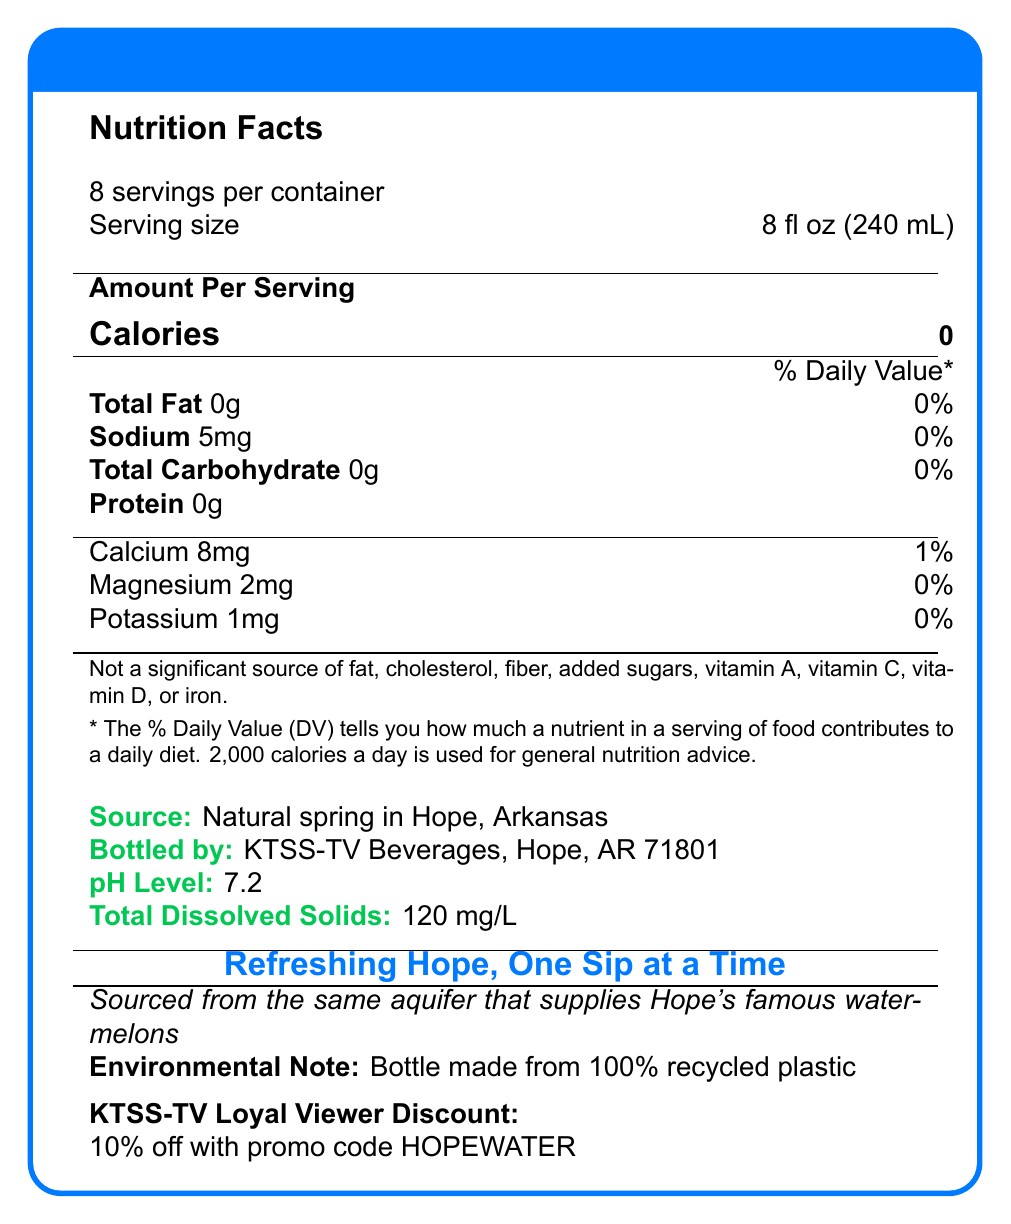What is the sodium content per serving of KTSS-TV Spring Water? The document lists "Sodium" with an amount of "5mg" per serving in the Nutrition Facts section.
Answer: 5 mg What is the daily value percentage of Calcium in a serving of KTSS-TV Spring Water? The document shows "Calcium" with an amount of "8mg" and a daily value percentage of "1%" in the Nutrition Facts section.
Answer: 1% How many servings are there in one container of KTSS-TV Spring Water? The document states "8 servings per container" under the Nutrition Facts header.
Answer: 8 Which minerals are listed in the Nutrition Facts of KTSS-TV Spring Water? The document lists "Calcium", "Magnesium", and "Potassium" with their respective amounts and daily values in the Nutrition Facts section.
Answer: Calcium, Magnesium, Potassium What is the pH level of KTSS-TV Spring Water? The document specifies a "pH Level" of "7.2" in the additional information section.
Answer: 7.2 What is the source of KTSS-TV Spring Water? A. Natural spring in Little Rock, AR B. Natural spring in Hope, AR C. Natural spring in Texarkana, AR The document specifies that the source is a "Natural spring in Hope, Arkansas."
Answer: B What is the amount of total dissolved solids in KTSS-TV Spring Water? A. 100 mg/L B. 110 mg/L C. 120 mg/L The document states "Total Dissolved Solids: 120 mg/L" in the environmental information section.
Answer: C Which nutrient is not a significant source in KTSS-TV Spring Water? A. Vitamin A B. Iron C. Fiber D. All of the above The FDA statement in the document mentions all listed nutrients including vitamin A, iron, and fiber as not significant sources.
Answer: D Is KTSS-TV Spring Water a good source of protein? The Nutrition Facts label indicates that the water contains "0g" of protein per serving.
Answer: No Summarize the main idea of the KTSS-TV Spring Water document. KTSS-TV Spring Water offers a healthy hydration option with minimal mineral content, sourced locally and packaged in environmentally friendly bottles, emphasizing its connection to the Hope, Arkansas community.
Answer: KTSS-TV Spring Water is a bottled water product with no calories, fat, carbs, or protein. It contains small amounts of sodium, calcium, magnesium, and potassium. The water is sourced from a natural spring in Hope, Arkansas, has a pH level of 7.2, and has 120 mg/L of total dissolved solids. The bottle is made from recycled plastic, and loyal viewers can get a 10% discount with a promo code. What is the packaging material for the KTSS-TV Spring Water bottle? The document mentions "Bottle made from 100% recycled plastic" in the environmental note section.
Answer: Bottle made from 100% recycled plastic What promotional offer is available for KTSS-TV loyal viewers? The document states "10% off with promo code HOPEWATER" under the KTSS-TV Loyal Viewer Discount section.
Answer: 10% off with promo code HOPEWATER How much potassium is in one serving of KTSS-TV Spring Water? The document lists "Potassium 1mg" in the Nutrition Facts section.
Answer: 1 mg How much nutritional intake does the KTSS-TV Spring Water provide in terms of fat? The document lists "Total Fat" as "0g" with a daily value of "0%" in the Nutrition Facts section.
Answer: 0% What is the FDA statement included in the KTSS-TV Spring Water's Nutrition Facts? The document includes this statement in the footer of the Nutrition Facts section.
Answer: Not a significant source of fat, cholesterol, fiber, added sugars, vitamin A, vitamin C, vitamin D, or iron. How much water does one serving of KTSS-TV Spring Water contain in fluid ounces? The document specifies the serving size as "8 fl oz (240 mL)" under the Nutrition Facts header.
Answer: 8 fl oz What is the slogan of KTSS-TV Spring Water? The document prominently displays the slogan "Refreshing Hope, One Sip at a Time" in the design.
Answer: Refreshing Hope, One Sip at a Time Where is the KTSS-TV Spring Water bottled? The document states that KTSS-TV Spring Water is bottled by "KTSS-TV Beverages, Hope, AR 71801."
Answer: Hope, AR 71801 From which specific aquifer is KTSS-TV Spring Water sourced? The document mentions that the water is "Sourced from the same aquifer that supplies Hope's famous watermelons," but does not specify the exact name of the aquifer.
Answer: Cannot be determined What is the calorie content of KTSS-TV Spring Water per serving? The document states "Calories 0" per serving in the Nutrition Facts section.
Answer: 0 